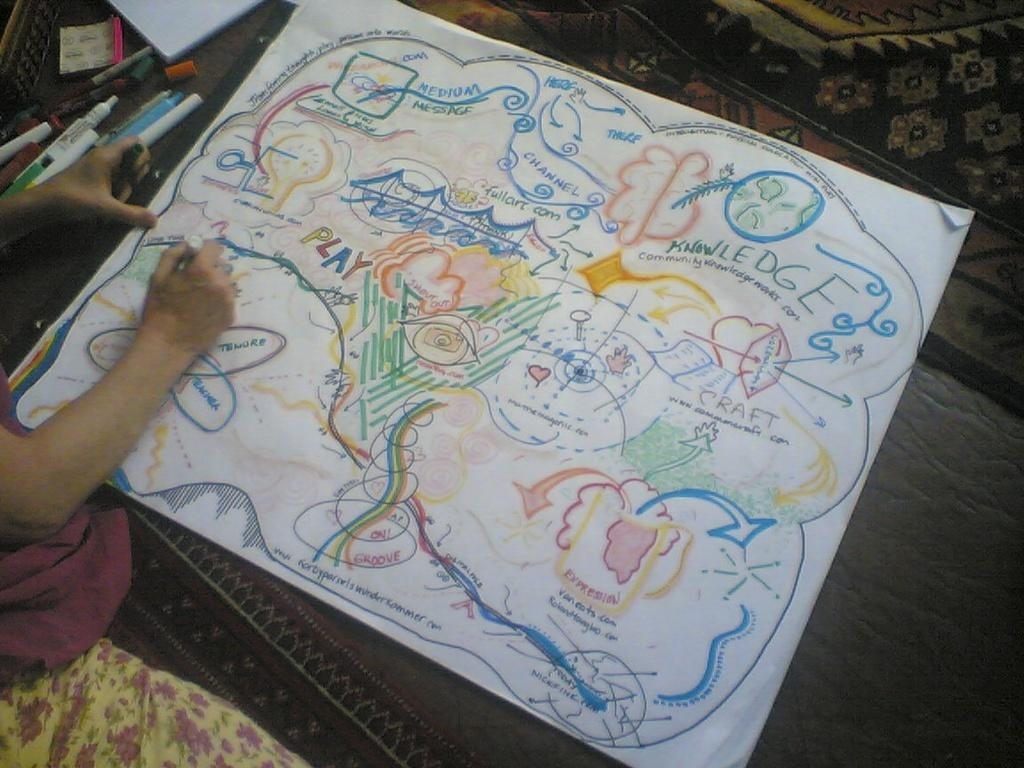What is the main subject of the image? The main subject of the image is a drawing. What elements are included in the drawing? The drawing includes images and text. What body parts are visible in the image? Human hands are visible in the image. Are there any other objects or elements in the image besides the drawing? Yes, there are other unspecified objects in the image. What type of cast is being worn by the mom in the image? There is no mom or cast present in the image; it features a drawing with human hands and other unspecified objects. How many boats are visible in the image? There are no boats visible in the image; it features a drawing with images and text. 